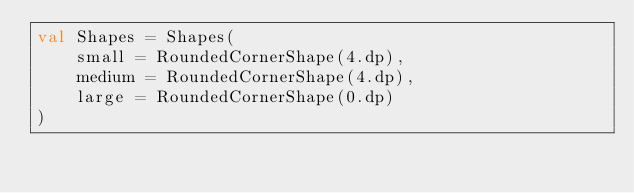Convert code to text. <code><loc_0><loc_0><loc_500><loc_500><_Kotlin_>val Shapes = Shapes(
    small = RoundedCornerShape(4.dp),
    medium = RoundedCornerShape(4.dp),
    large = RoundedCornerShape(0.dp)
)</code> 